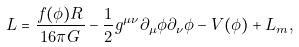<formula> <loc_0><loc_0><loc_500><loc_500>L = \frac { f ( \phi ) R } { 1 6 \pi G } - \frac { 1 } { 2 } g ^ { \mu \nu } \partial _ { \mu } \phi \partial _ { \nu } \phi - V ( \phi ) + L _ { m } ,</formula> 